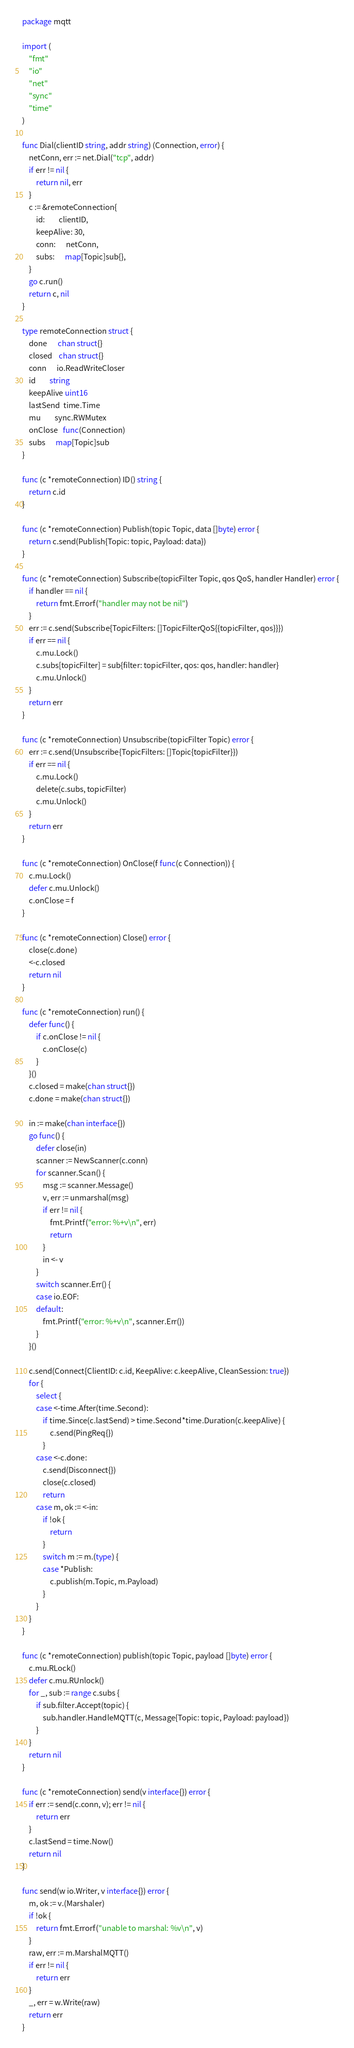Convert code to text. <code><loc_0><loc_0><loc_500><loc_500><_Go_>package mqtt

import (
	"fmt"
	"io"
	"net"
	"sync"
	"time"
)

func Dial(clientID string, addr string) (Connection, error) {
	netConn, err := net.Dial("tcp", addr)
	if err != nil {
		return nil, err
	}
	c := &remoteConnection{
		id:        clientID,
		keepAlive: 30,
		conn:      netConn,
		subs:      map[Topic]sub{},
	}
	go c.run()
	return c, nil
}

type remoteConnection struct {
	done      chan struct{}
	closed    chan struct{}
	conn      io.ReadWriteCloser
	id        string
	keepAlive uint16
	lastSend  time.Time
	mu        sync.RWMutex
	onClose   func(Connection)
	subs      map[Topic]sub
}

func (c *remoteConnection) ID() string {
	return c.id
}

func (c *remoteConnection) Publish(topic Topic, data []byte) error {
	return c.send(Publish{Topic: topic, Payload: data})
}

func (c *remoteConnection) Subscribe(topicFilter Topic, qos QoS, handler Handler) error {
	if handler == nil {
		return fmt.Errorf("handler may not be nil")
	}
	err := c.send(Subscribe{TopicFilters: []TopicFilterQoS{{topicFilter, qos}}})
	if err == nil {
		c.mu.Lock()
		c.subs[topicFilter] = sub{filter: topicFilter, qos: qos, handler: handler}
		c.mu.Unlock()
	}
	return err
}

func (c *remoteConnection) Unsubscribe(topicFilter Topic) error {
	err := c.send(Unsubscribe{TopicFilters: []Topic{topicFilter}})
	if err == nil {
		c.mu.Lock()
		delete(c.subs, topicFilter)
		c.mu.Unlock()
	}
	return err
}

func (c *remoteConnection) OnClose(f func(c Connection)) {
	c.mu.Lock()
	defer c.mu.Unlock()
	c.onClose = f
}

func (c *remoteConnection) Close() error {
	close(c.done)
	<-c.closed
	return nil
}

func (c *remoteConnection) run() {
	defer func() {
		if c.onClose != nil {
			c.onClose(c)
		}
	}()
	c.closed = make(chan struct{})
	c.done = make(chan struct{})

	in := make(chan interface{})
	go func() {
		defer close(in)
		scanner := NewScanner(c.conn)
		for scanner.Scan() {
			msg := scanner.Message()
			v, err := unmarshal(msg)
			if err != nil {
				fmt.Printf("error: %+v\n", err)
				return
			}
			in <- v
		}
		switch scanner.Err() {
		case io.EOF:
		default:
			fmt.Printf("error: %+v\n", scanner.Err())
		}
	}()

	c.send(Connect{ClientID: c.id, KeepAlive: c.keepAlive, CleanSession: true})
	for {
		select {
		case <-time.After(time.Second):
			if time.Since(c.lastSend) > time.Second*time.Duration(c.keepAlive) {
				c.send(PingReq{})
			}
		case <-c.done:
			c.send(Disconnect{})
			close(c.closed)
			return
		case m, ok := <-in:
			if !ok {
				return
			}
			switch m := m.(type) {
			case *Publish:
				c.publish(m.Topic, m.Payload)
			}
		}
	}
}

func (c *remoteConnection) publish(topic Topic, payload []byte) error {
	c.mu.RLock()
	defer c.mu.RUnlock()
	for _, sub := range c.subs {
		if sub.filter.Accept(topic) {
			sub.handler.HandleMQTT(c, Message{Topic: topic, Payload: payload})
		}
	}
	return nil
}

func (c *remoteConnection) send(v interface{}) error {
	if err := send(c.conn, v); err != nil {
		return err
	}
	c.lastSend = time.Now()
	return nil
}

func send(w io.Writer, v interface{}) error {
	m, ok := v.(Marshaler)
	if !ok {
		return fmt.Errorf("unable to marshal: %v\n", v)
	}
	raw, err := m.MarshalMQTT()
	if err != nil {
		return err
	}
	_, err = w.Write(raw)
	return err
}
</code> 